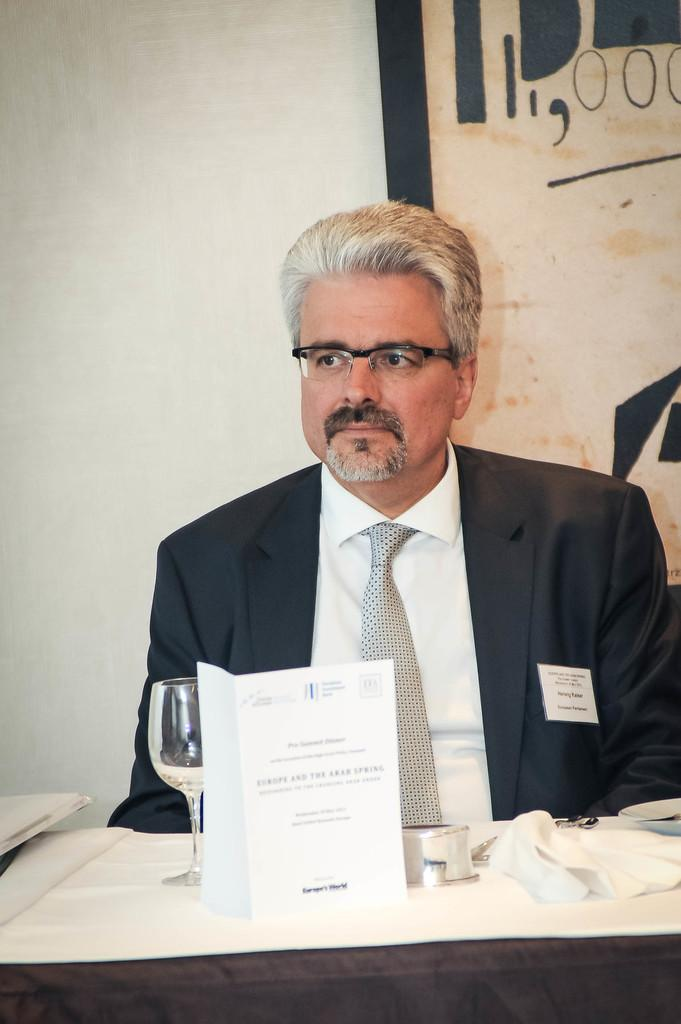What is the man in the image doing? The man is sitting on a chair in the image. What objects are on the table in the image? There is a glass, tissue, paper, and a book on the table in the image. What is hanging on the wall behind the man? There is a frame on the wall behind the man. What type of pies can be seen on the table in the image? There are no pies present on the table in the image. How does the man contribute to pollution in the image? The image does not provide any information about pollution or the man's contribution to it. 